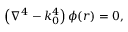<formula> <loc_0><loc_0><loc_500><loc_500>\left ( \nabla ^ { 4 } - k _ { 0 } ^ { 4 } \right ) \phi ( r ) = 0 ,</formula> 